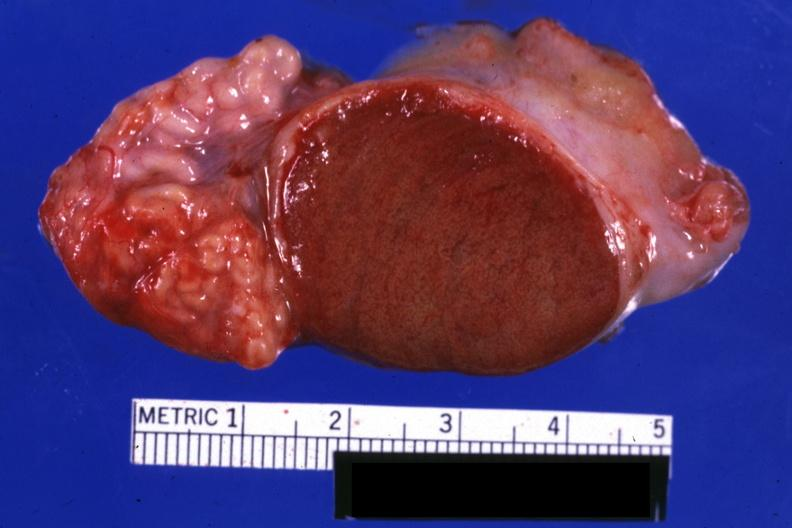how is excellent close-up view sliced open testicle with epididymis?
Answer the question using a single word or phrase. Intact 